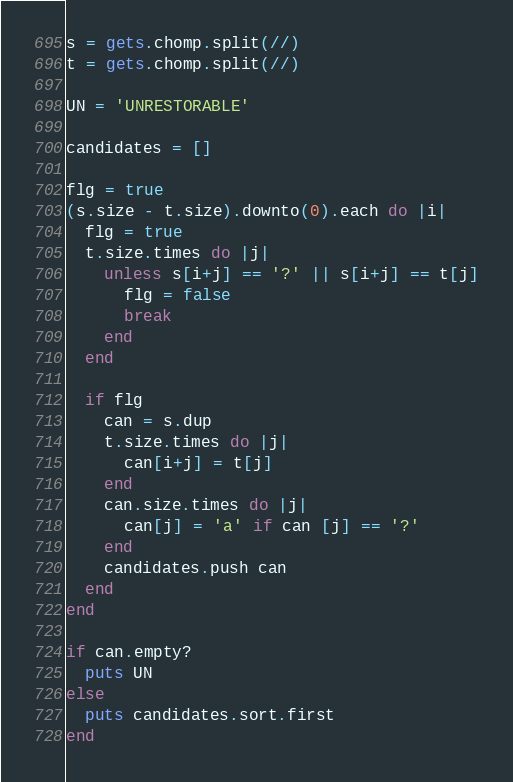<code> <loc_0><loc_0><loc_500><loc_500><_Ruby_>s = gets.chomp.split(//)
t = gets.chomp.split(//)

UN = 'UNRESTORABLE'

candidates = []

flg = true
(s.size - t.size).downto(0).each do |i|
  flg = true
  t.size.times do |j|
    unless s[i+j] == '?' || s[i+j] == t[j]
      flg = false
      break
    end
  end

  if flg
    can = s.dup
    t.size.times do |j|
      can[i+j] = t[j]
    end
    can.size.times do |j|
      can[j] = 'a' if can [j] == '?'
    end
    candidates.push can
  end
end

if can.empty?
  puts UN
else
  puts candidates.sort.first
end
</code> 